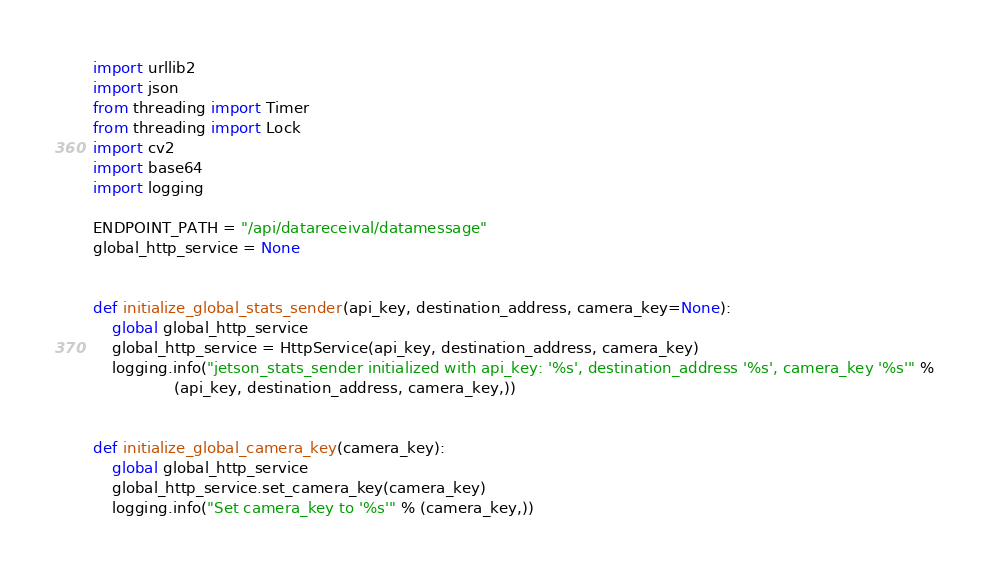Convert code to text. <code><loc_0><loc_0><loc_500><loc_500><_Python_>import urllib2
import json
from threading import Timer
from threading import Lock
import cv2
import base64
import logging

ENDPOINT_PATH = "/api/datareceival/datamessage"
global_http_service = None


def initialize_global_stats_sender(api_key, destination_address, camera_key=None):
    global global_http_service
    global_http_service = HttpService(api_key, destination_address, camera_key)
    logging.info("jetson_stats_sender initialized with api_key: '%s', destination_address '%s', camera_key '%s'" %
                 (api_key, destination_address, camera_key,))


def initialize_global_camera_key(camera_key):
    global global_http_service
    global_http_service.set_camera_key(camera_key)
    logging.info("Set camera_key to '%s'" % (camera_key,))

</code> 